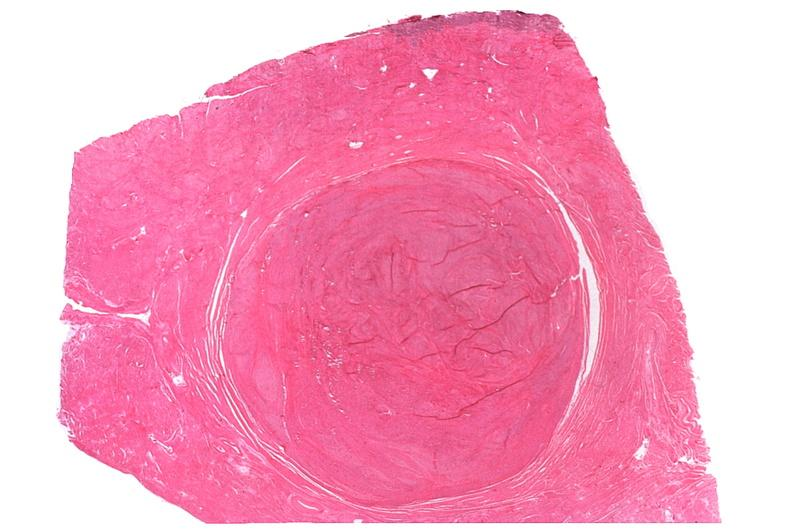does atheromatous embolus show uterus, leiomyomas?
Answer the question using a single word or phrase. No 